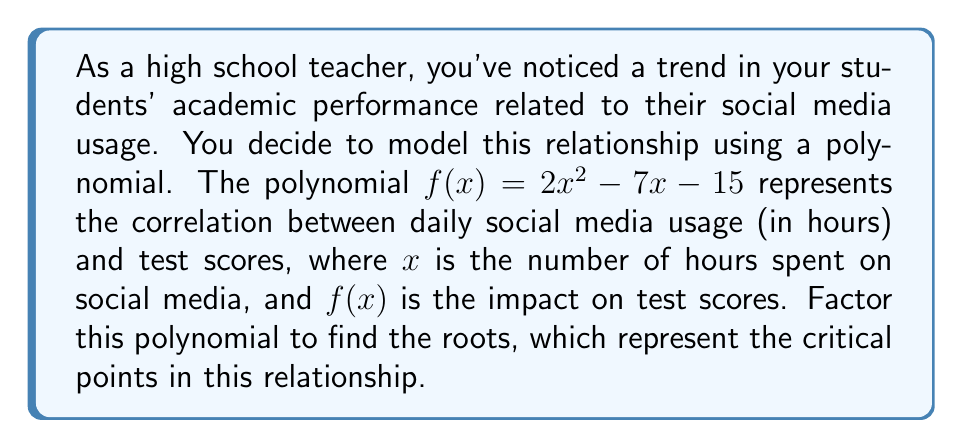Teach me how to tackle this problem. To factor this quadratic polynomial, we'll use the following steps:

1) First, let's identify the coefficients:
   $a = 2$, $b = -7$, and $c = -15$

2) We'll use the quadratic formula: $x = \frac{-b \pm \sqrt{b^2 - 4ac}}{2a}$

3) Let's calculate the discriminant $(b^2 - 4ac)$:
   $(-7)^2 - 4(2)(-15) = 49 + 120 = 169$

4) Now we can plug this into the quadratic formula:
   $x = \frac{7 \pm \sqrt{169}}{2(2)} = \frac{7 \pm 13}{4}$

5) This gives us two solutions:
   $x_1 = \frac{7 + 13}{4} = \frac{20}{4} = 5$
   $x_2 = \frac{7 - 13}{4} = -\frac{6}{4} = -\frac{3}{2}$

6) Now that we have the roots, we can factor the polynomial:
   $f(x) = 2(x - 5)(x + \frac{3}{2})$

This factored form shows that the critical points in the relationship between social media usage and test scores occur at 5 hours and -1.5 hours of daily social media use. The negative value isn't meaningful in this context, but the positive root suggests that 5 hours of daily social media use might be a turning point in its impact on test scores.
Answer: $f(x) = 2(x - 5)(x + \frac{3}{2})$ 